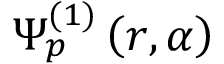<formula> <loc_0><loc_0><loc_500><loc_500>\Psi _ { p } ^ { ( 1 ) } \left ( r , \alpha \right )</formula> 